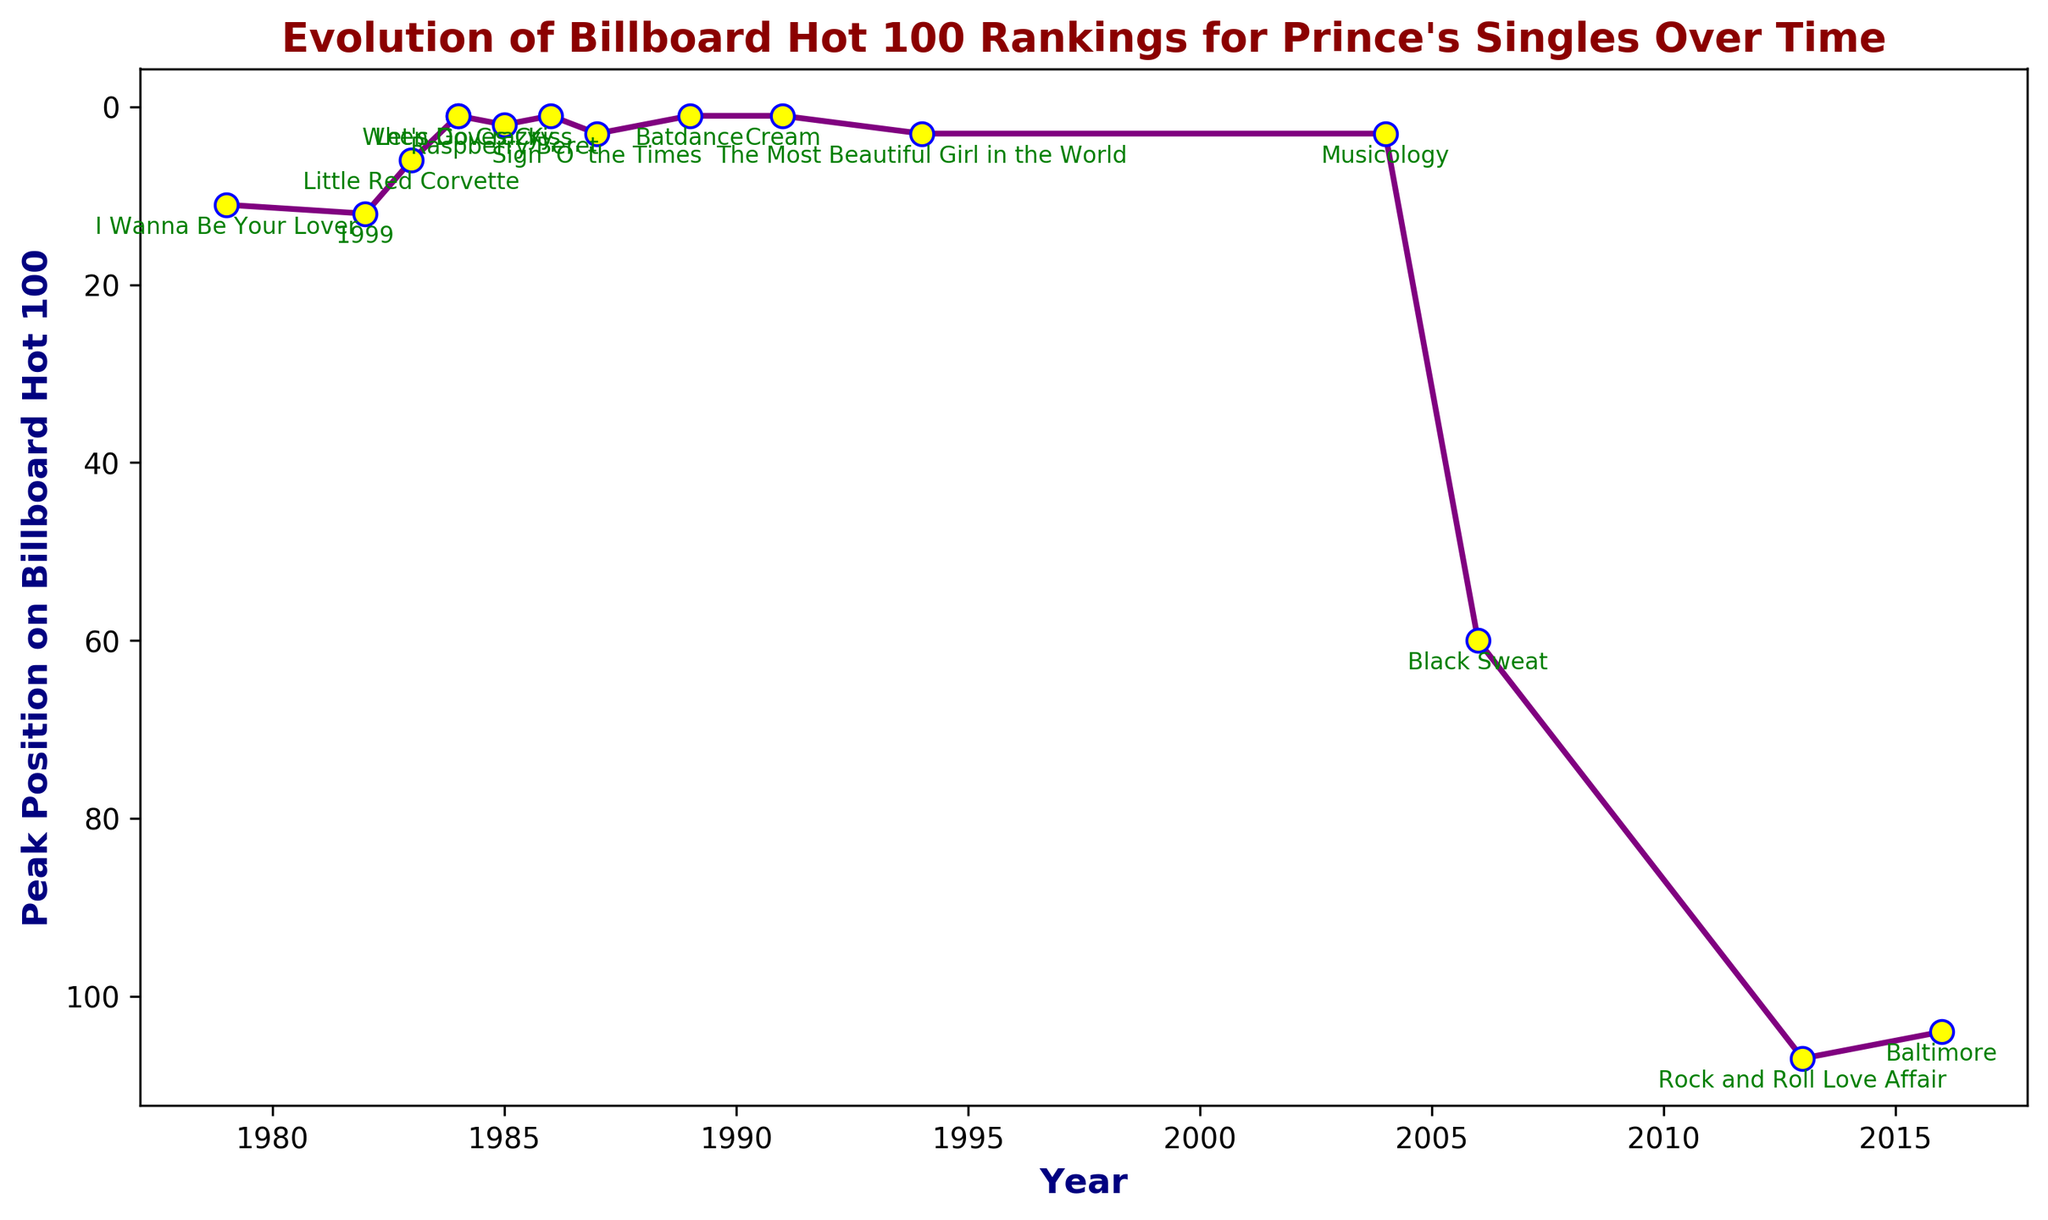What are the years in which Prince's singles peaked at No. 1 on the Billboard Hot 100? From the plot, identify the singles which reached the peak position of 1. The corresponding years are 1984 ('When Doves Cry' and 'Let's Go Crazy'), 1986 ('Kiss'), 1989 ('Batdance'), and 1991 ('Cream').
Answer: 1984, 1986, 1989, 1991 Which single had the lowest peak position, and what year did it occur? Identify the highest point on the inverted y-axis, which represents the lowest peak position. It is 'Rock and Roll Love Affair' in 2013 with a peak position of 107.
Answer: 'Rock and Roll Love Affair', 2013 Between 'Raspberry Beret' and 'Kiss', which single peaked higher on the Billboard Hot 100, and by how much? Locate the peak positions of 'Raspberry Beret' and 'Kiss' on the y-axis. 'Raspberry Beret' peaked at 2, while 'Kiss' peaked at 1. The difference in peak position is 1.
Answer: 'Kiss', by 1 What trend do you observe in the peak positions of Prince's singles from 1979 to 2016? Assess the general placement of points from 1979 to 2016. Initially, several singles hit the top ranks, with a mix of higher and lower peaks over time, and a noticeable decline after 2004.
Answer: Early success, decline over time Calculate the average peak position of Prince's singles in the 1980s (1980-1989). Identify the singles from the 1980s: '1999', 'Little Red Corvette', 'When Doves Cry', 'Let's Go Crazy', 'Raspberry Beret', 'Kiss', and 'Sign 'O' the Times', and 'Batdance'. Their peak positions are 12, 6, 1, 1, 2, 1, 3, 1. Sum these (12+6+1+1+2+1+3+1) = 27. The average is 27/8 = 3.375.
Answer: 3.375 Which decade had the highest average peak position for Prince's singles? Compare the averages for each decade: 1980s (3.375 as calculated above), 1990s ('Cream' (1) and 'The Most Beautiful Girl in the World' (3): average = (1+3)/2 = 2), 2000s ('Musicology' and 'Black Sweat': average = (3+60)/2 = 31.5), and 2010s ('Rock and Roll Love Affair' and 'Baltimore': average = (107+104)/2 = 105.5). The 1990s have the highest average peak position (2).
Answer: 1990s How many singles reached the top 10 between 1980 and 2000? Identify singles within 1980-2000 and their positions in the top 10: '1999' (12), 'Little Red Corvette' (6), 'When Doves Cry' (1), 'Let's Go Crazy' (1), 'Raspberry Beret' (2), 'Kiss' (1), 'Sign 'O' the Times' (3), 'Batdance' (1), and 'Cream' (1). Count those within the top 10 (6, 1, 1, 2, 1, 3, 1, 1): 8 singles.
Answer: 8 What is the difference in peak positions between 'I Wanna Be Your Lover' and 'Baltimore'? Locate the peak positions of 'I Wanna Be Your Lover' (11) and 'Baltimore' (104). The difference is 104 - 11 = 93.
Answer: 93 What visual pattern is noticeable for singles from the 2000s and later? Observe the positions for singles from 2000s onwards: 'Musicology' (2004) peaks at 3, but after that, singles like 'Black Sweat' (60), 'Rock and Roll Love Affair' (107), and 'Baltimore' (104) have higher peak positions (lower ranks). The pattern shows a decline in chart success.
Answer: Declining chart success 